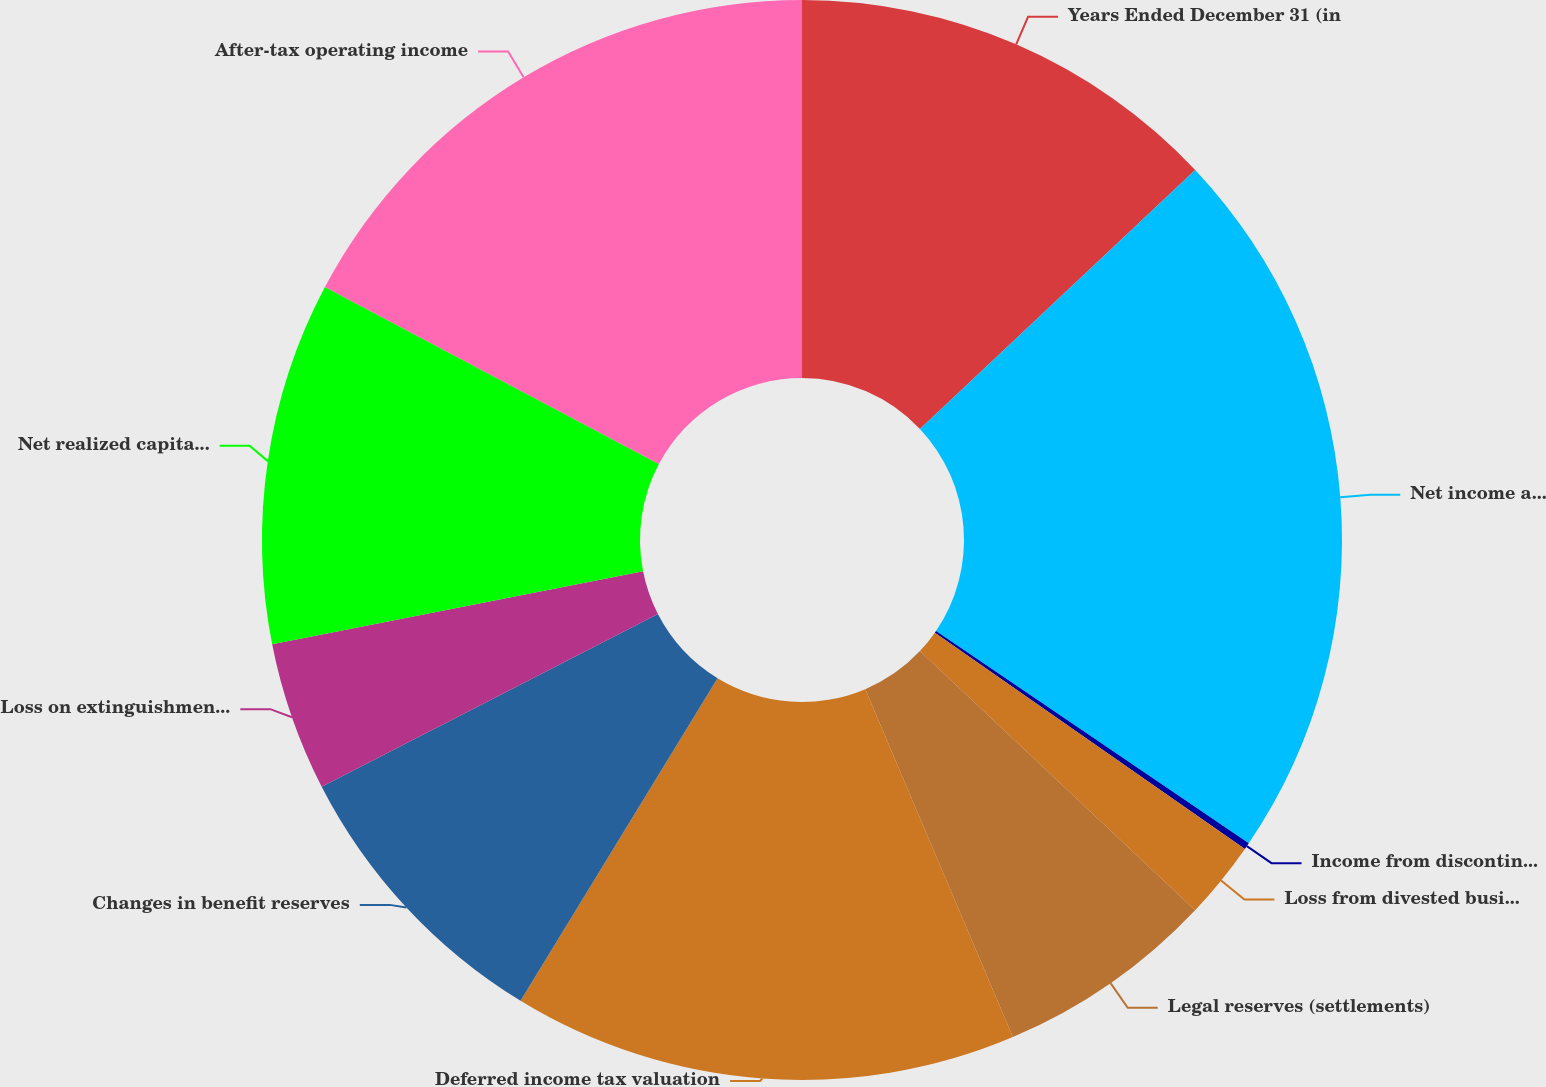<chart> <loc_0><loc_0><loc_500><loc_500><pie_chart><fcel>Years Ended December 31 (in<fcel>Net income attributable to AIG<fcel>Income from discontinued<fcel>Loss from divested businesses<fcel>Legal reserves (settlements)<fcel>Deferred income tax valuation<fcel>Changes in benefit reserves<fcel>Loss on extinguishment of debt<fcel>Net realized capital gains<fcel>After-tax operating income<nl><fcel>12.98%<fcel>21.51%<fcel>0.2%<fcel>2.33%<fcel>6.59%<fcel>15.11%<fcel>8.72%<fcel>4.46%<fcel>10.85%<fcel>17.24%<nl></chart> 